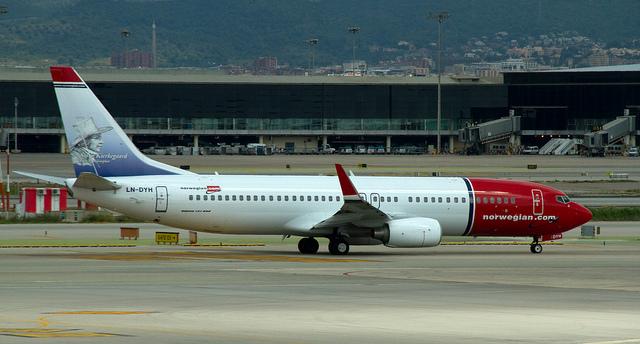Where is the plane at?
Quick response, please. Airport. What color is the nose of the plane?
Keep it brief. Red. Is there a picture on the tail of the plane?
Write a very short answer. Yes. 